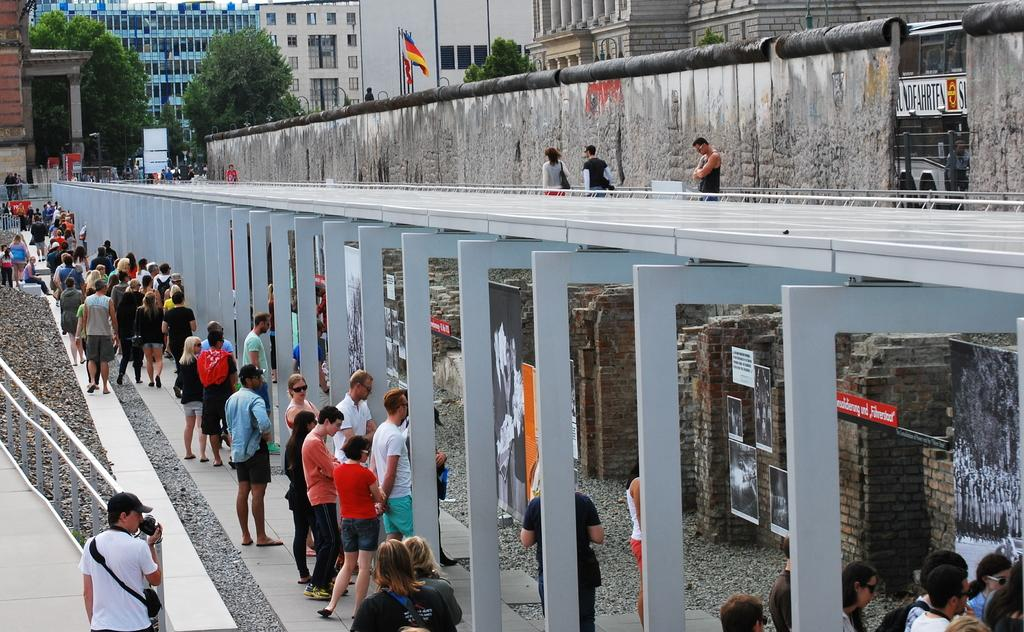What is happening in the image? There are persons standing in the image. What can be seen beside the persons? There are poles beside the persons. What is visible in the background of the image? There are trees and buildings in the background of the image. What type of neck can be seen on the persons in the image? There is no mention of any necks or musical instruments in the image, so it cannot be determined from the image. 